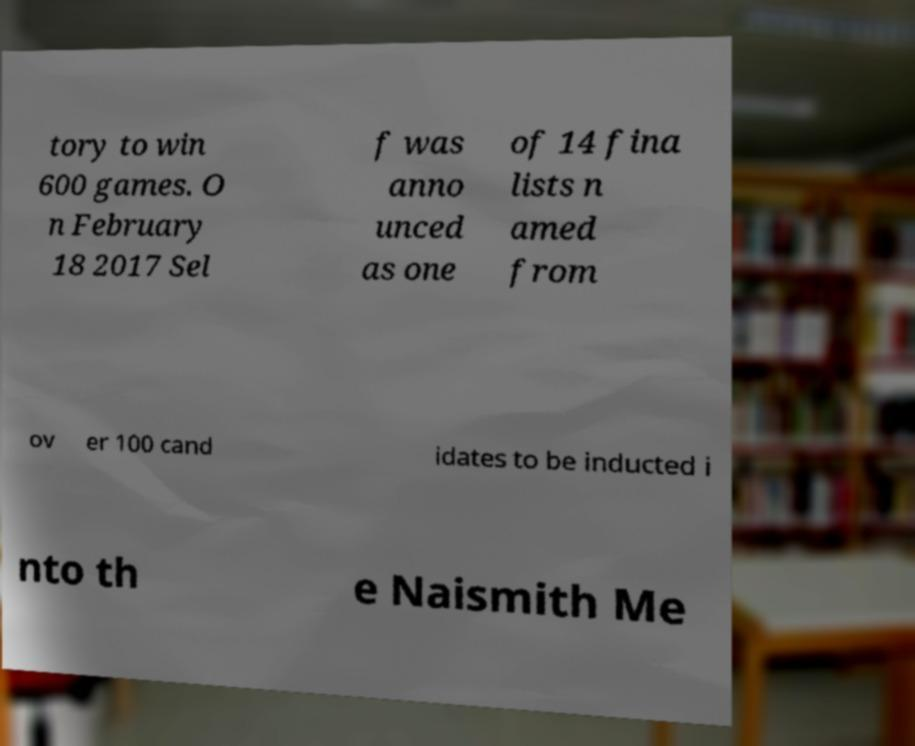There's text embedded in this image that I need extracted. Can you transcribe it verbatim? tory to win 600 games. O n February 18 2017 Sel f was anno unced as one of 14 fina lists n amed from ov er 100 cand idates to be inducted i nto th e Naismith Me 